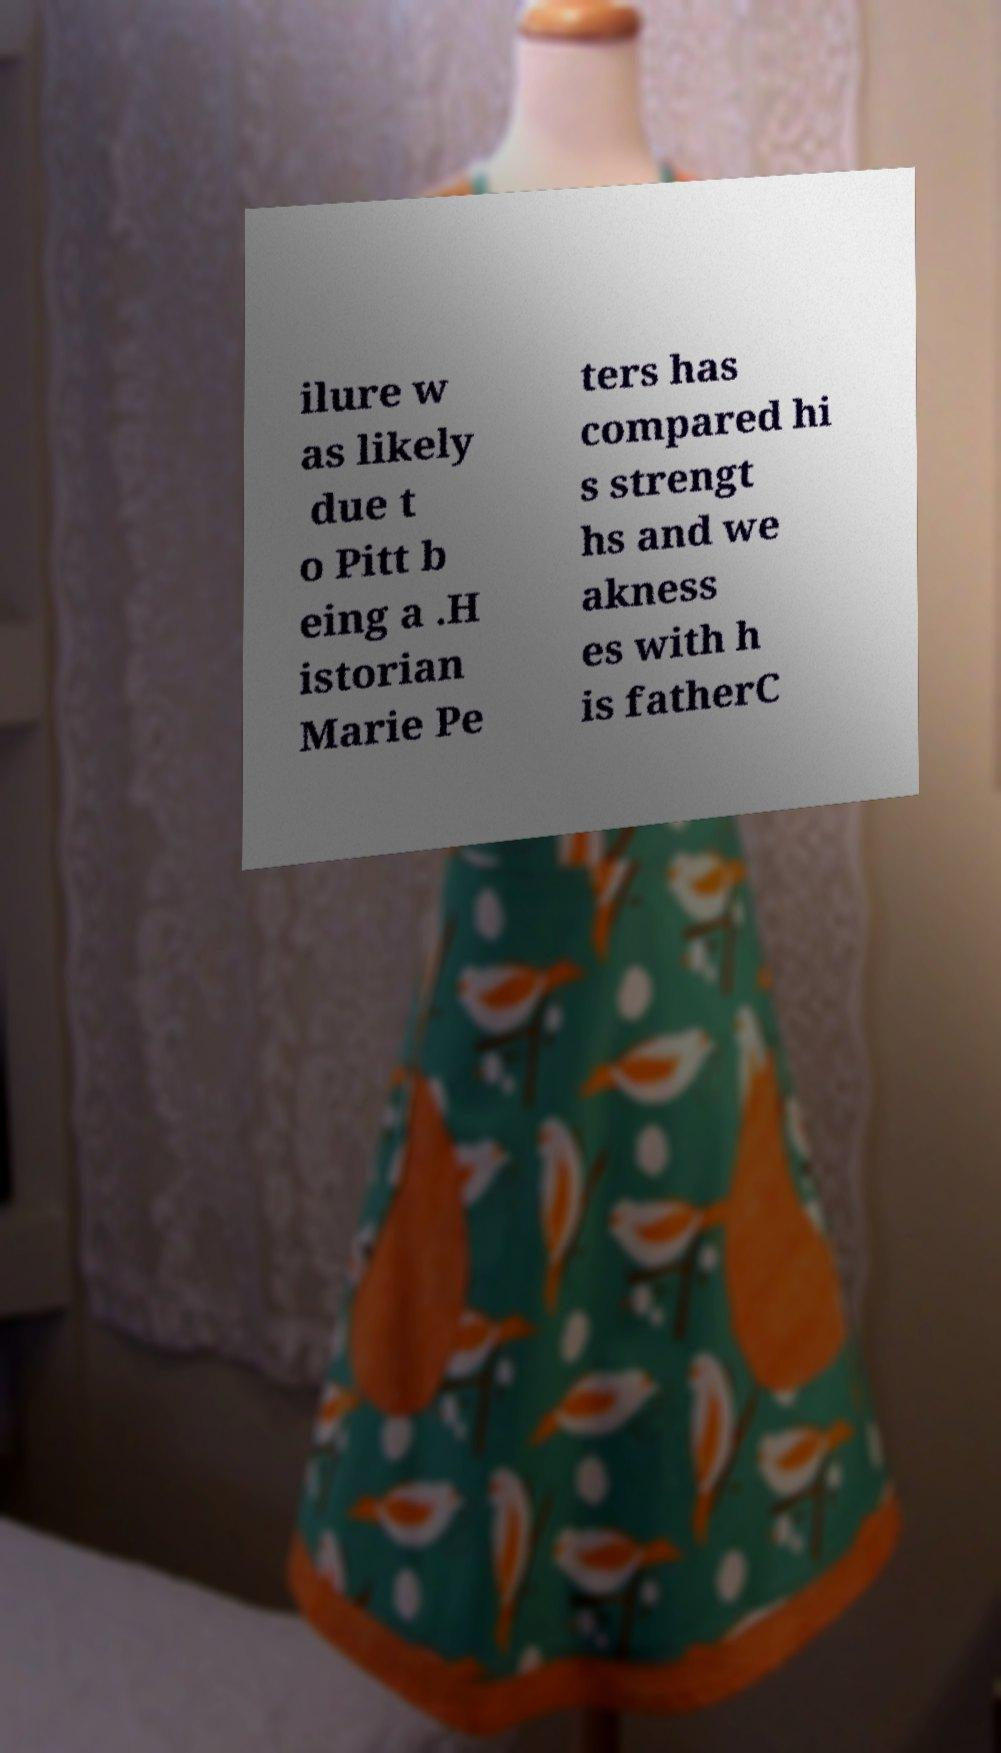What messages or text are displayed in this image? I need them in a readable, typed format. ilure w as likely due t o Pitt b eing a .H istorian Marie Pe ters has compared hi s strengt hs and we akness es with h is fatherC 